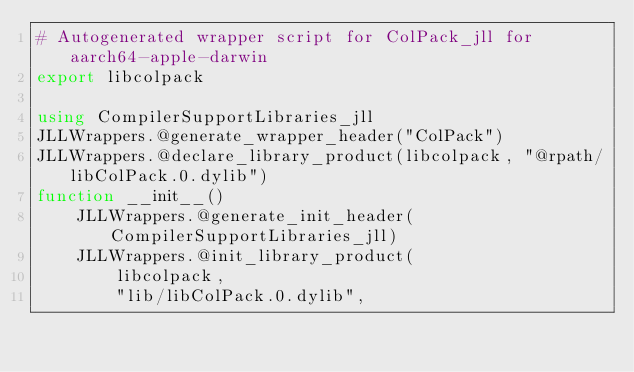Convert code to text. <code><loc_0><loc_0><loc_500><loc_500><_Julia_># Autogenerated wrapper script for ColPack_jll for aarch64-apple-darwin
export libcolpack

using CompilerSupportLibraries_jll
JLLWrappers.@generate_wrapper_header("ColPack")
JLLWrappers.@declare_library_product(libcolpack, "@rpath/libColPack.0.dylib")
function __init__()
    JLLWrappers.@generate_init_header(CompilerSupportLibraries_jll)
    JLLWrappers.@init_library_product(
        libcolpack,
        "lib/libColPack.0.dylib",</code> 